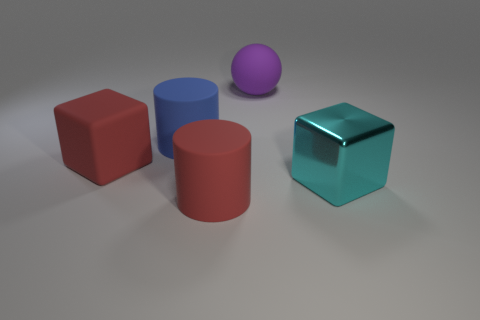Add 5 large gray shiny objects. How many objects exist? 10 Subtract all blocks. How many objects are left? 3 Subtract 0 gray blocks. How many objects are left? 5 Subtract all red rubber things. Subtract all big cyan objects. How many objects are left? 2 Add 3 rubber cubes. How many rubber cubes are left? 4 Add 2 rubber cubes. How many rubber cubes exist? 3 